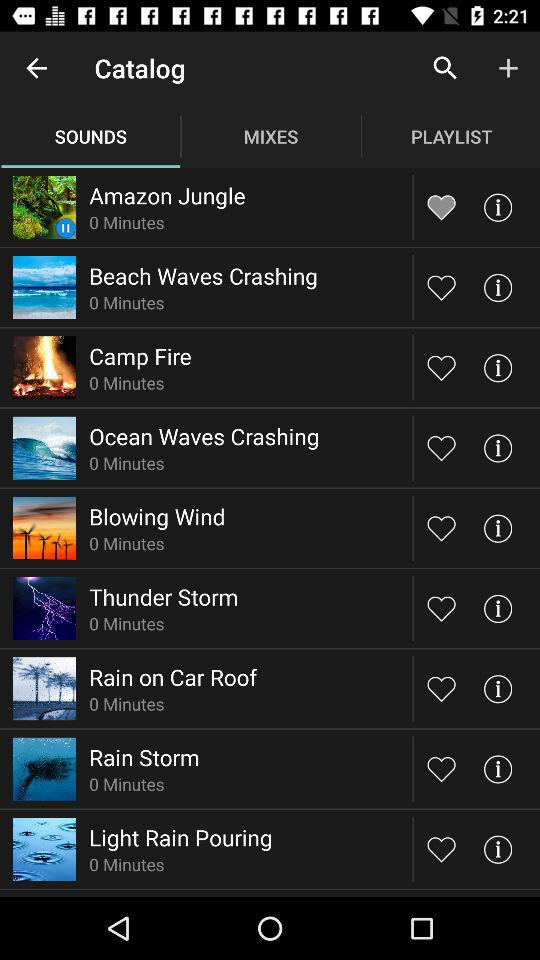Which sound has been liked? The sound that has been liked is "Amazon Jungle". 